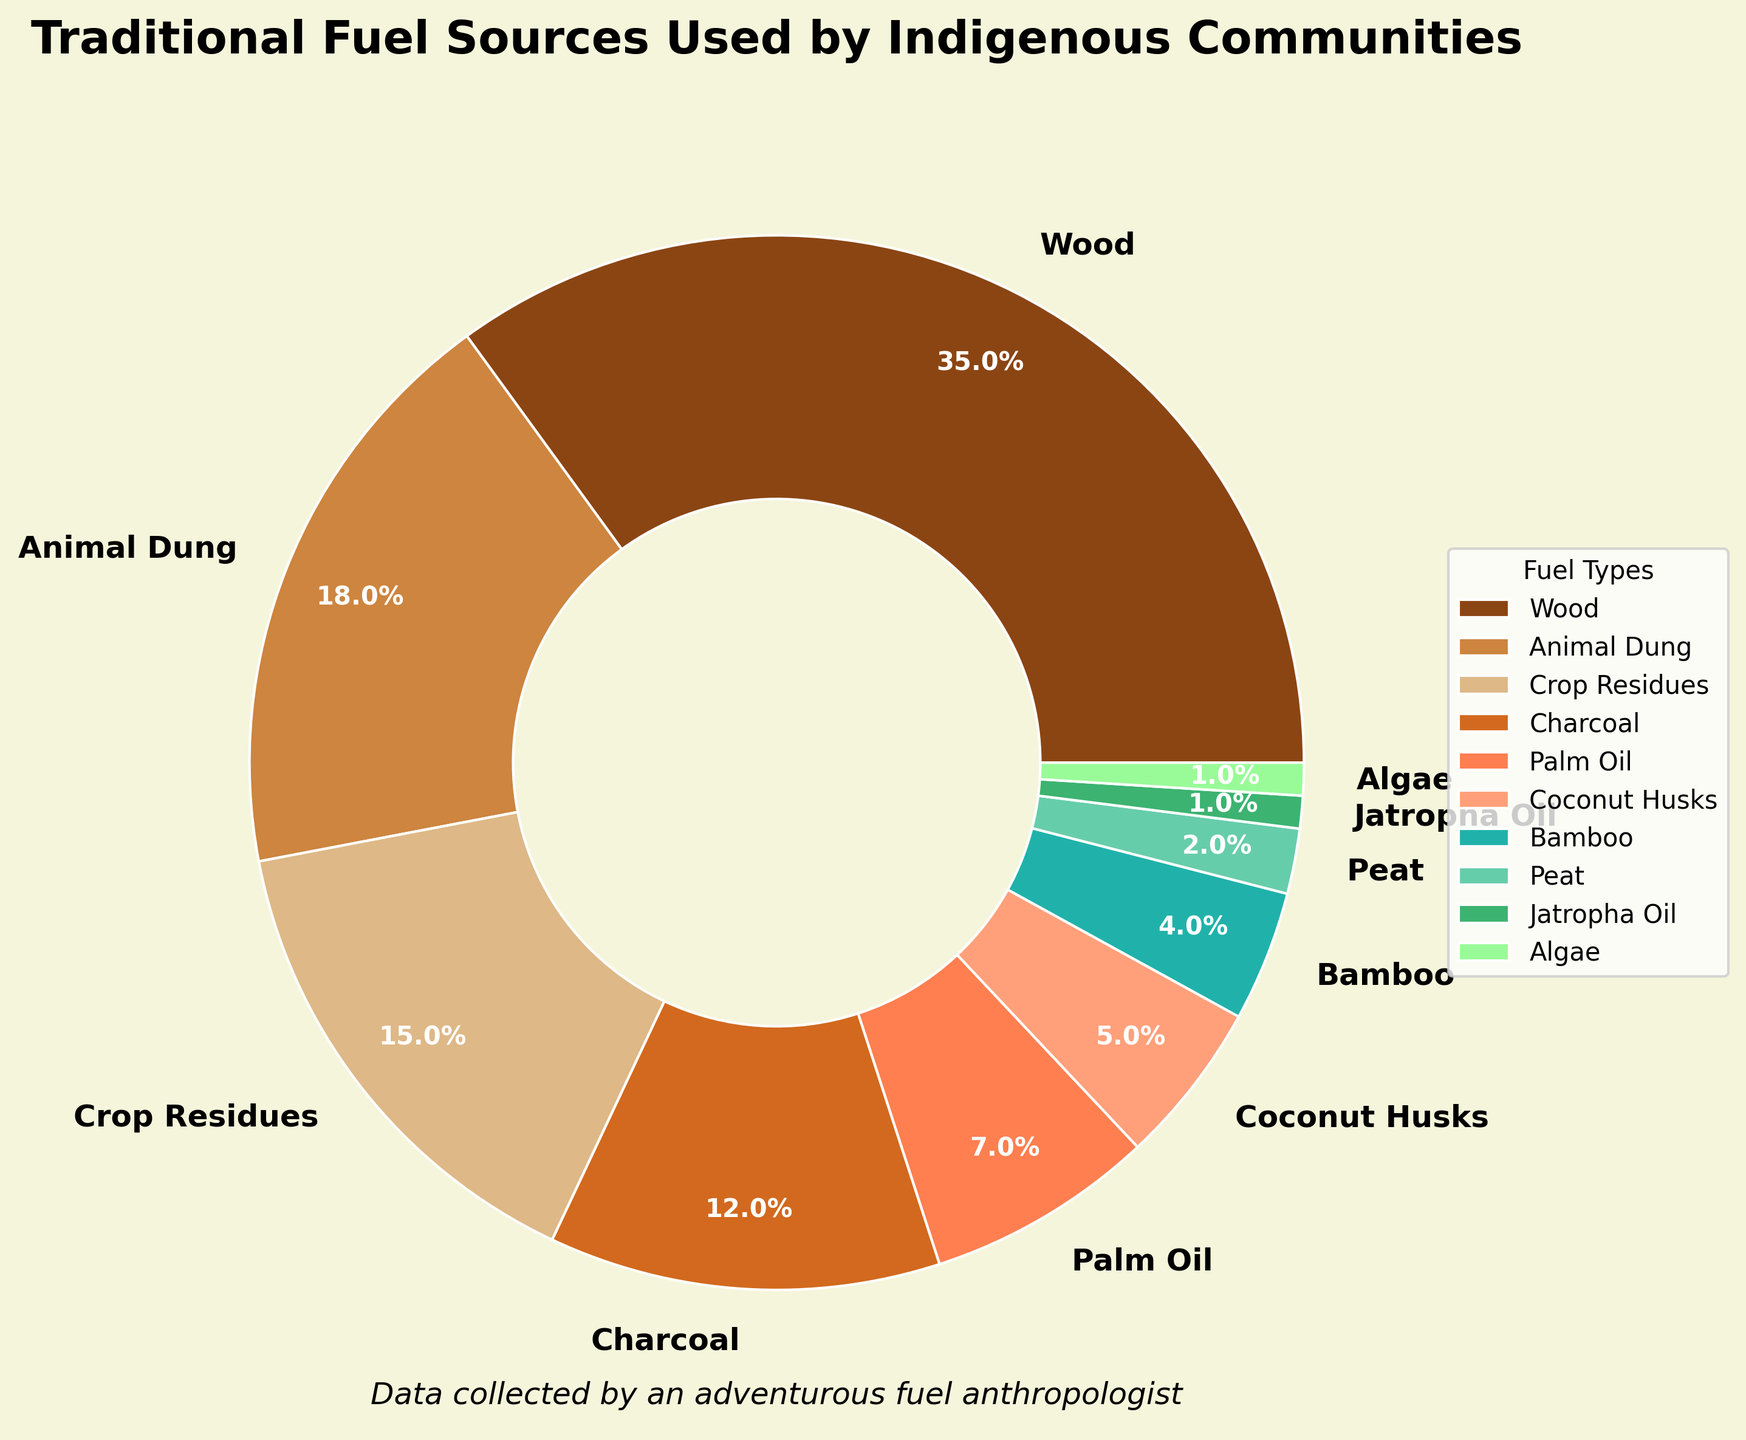Which fuel type is used the most among indigenous communities? The pie chart shows that wood has the largest segment with a percentage of 35%, making it the most used fuel type.
Answer: Wood Which two fuel types combined constitute exactly 20% of the total? The pie chart shows that Peat (2%) and Bamboo (4%) together make 6%, Animal Dung (18%) and Palm Oil (7%) together make 25%, but Jatropha Oil (1%) and Algae (1%) together make 2%. No two fuel types combined make exactly 20%.
Answer: None Which fuel types have similar usage percentages? The pie chart shows that Coconut Husks (5%) and Bamboo (4%) have close usage percentages, differing only by 1%.
Answer: Coconut Husks and Bamboo What is the total percentage of fuel usage attributed to Palm Oil, Coconut Husks, and Bamboo combined? Palm Oil is 7%, Coconut Husks is 5%, and Bamboo is 4%. Summing these percentages: 7% + 5% + 4% = 16%.
Answer: 16% Which color represents the fuel type with the smallest percentage? The pie chart uses a specific color scheme, but Jatropha Oil and Algae both share the smallest percentage at 1%.
Answer: Represented by the same color schemes as used in the chart Which fuel type's percentage is exactly half of that of Animal Dung's? The chart shows Animal Dung is 18%, half of which is 9%. No single fuel type has exactly 9%.
Answer: None How much more is the percentage of Charcoal compared to Bamboo? Charcoal is 12% and Bamboo is 4%. The difference between them is 12% - 4% = 8%.
Answer: 8% What is the difference in percentage between the most used and least used fuel types? The most used fuel type is Wood at 35%, and the least used are Jatropha Oil and Algae at 1%. The difference is 35% - 1% = 34%.
Answer: 34% Which segment occupies a larger area: Crop Residues or Charcoal? The chart shows Crop Residues at 15% and Charcoal at 12%. Crop Residues has a larger segment.
Answer: Crop Residues 